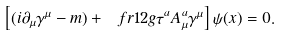Convert formula to latex. <formula><loc_0><loc_0><loc_500><loc_500>\left [ ( i \partial _ { \mu } \gamma ^ { \mu } - m ) + \ f r 1 2 g \tau ^ { a } A _ { \mu } ^ { a } \gamma ^ { \mu } \right ] \psi ( x ) = 0 .</formula> 